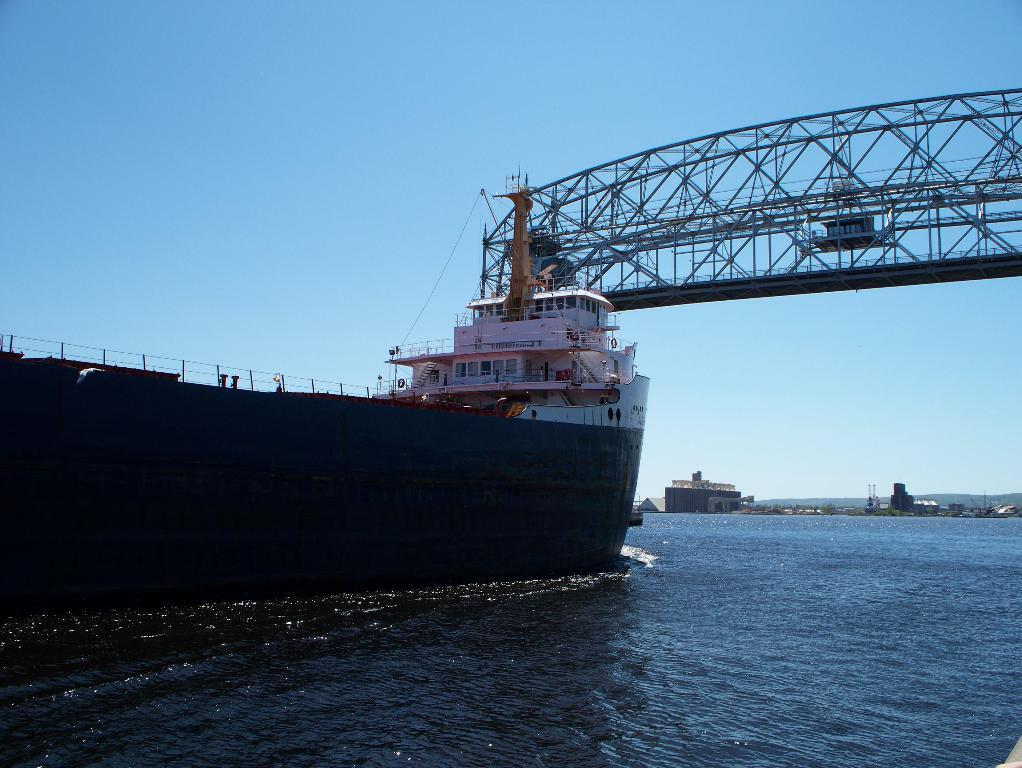What is the main subject of the image? The main subject of the image is a ship. What is the ship doing in the image? The ship is moving on the water. What other structures can be seen in the image? There is an iron bridge and a small building in the background of the image. What type of clam is being used as a propeller for the ship in the image? There is no clam present in the image, and the ship's propulsion is not mentioned. 